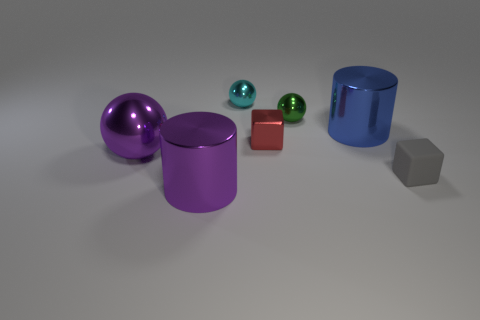What is the color of the shiny cylinder that is right of the cylinder that is in front of the gray block?
Provide a succinct answer. Blue. What material is the cyan object that is the same size as the green thing?
Make the answer very short. Metal. What number of matte things are either small green blocks or cyan balls?
Provide a short and direct response. 0. What color is the thing that is in front of the big ball and right of the cyan shiny ball?
Your response must be concise. Gray. How many big spheres are left of the tiny gray object?
Provide a succinct answer. 1. What is the material of the red thing?
Ensure brevity in your answer.  Metal. The cylinder behind the big purple object that is behind the purple thing in front of the gray rubber cube is what color?
Offer a terse response. Blue. How many other purple spheres are the same size as the purple sphere?
Provide a succinct answer. 0. There is a metal cylinder behind the small gray cube; what color is it?
Provide a succinct answer. Blue. How many other things are there of the same size as the purple cylinder?
Your answer should be compact. 2. 